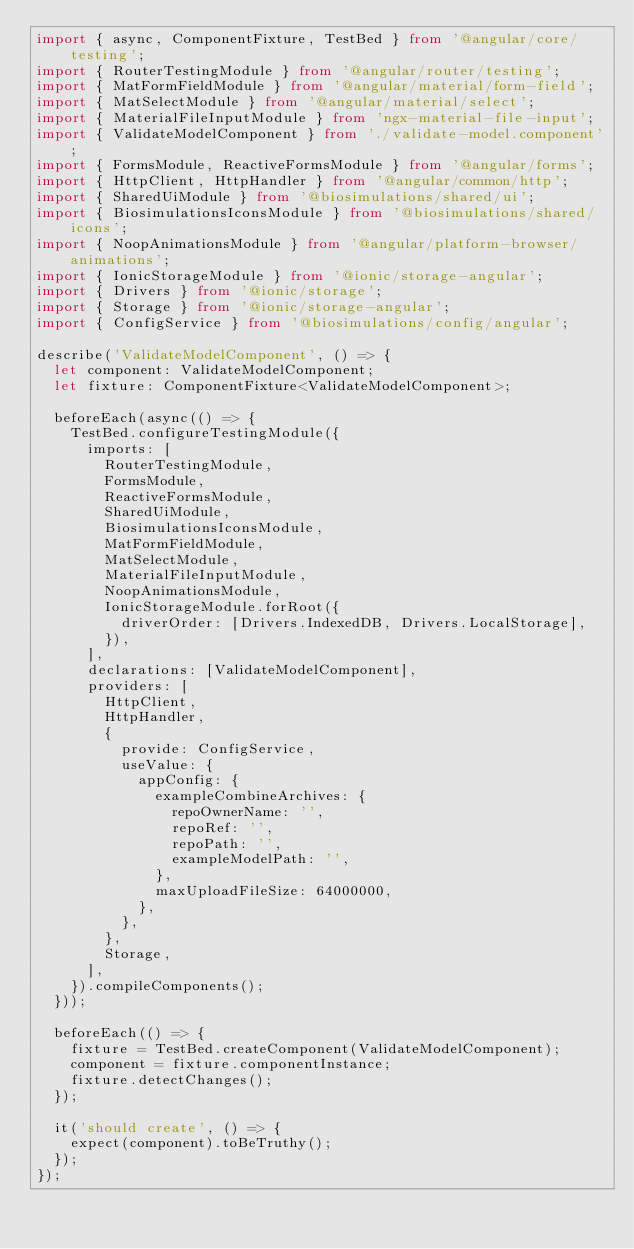Convert code to text. <code><loc_0><loc_0><loc_500><loc_500><_TypeScript_>import { async, ComponentFixture, TestBed } from '@angular/core/testing';
import { RouterTestingModule } from '@angular/router/testing';
import { MatFormFieldModule } from '@angular/material/form-field';
import { MatSelectModule } from '@angular/material/select';
import { MaterialFileInputModule } from 'ngx-material-file-input';
import { ValidateModelComponent } from './validate-model.component';
import { FormsModule, ReactiveFormsModule } from '@angular/forms';
import { HttpClient, HttpHandler } from '@angular/common/http';
import { SharedUiModule } from '@biosimulations/shared/ui';
import { BiosimulationsIconsModule } from '@biosimulations/shared/icons';
import { NoopAnimationsModule } from '@angular/platform-browser/animations';
import { IonicStorageModule } from '@ionic/storage-angular';
import { Drivers } from '@ionic/storage';
import { Storage } from '@ionic/storage-angular';
import { ConfigService } from '@biosimulations/config/angular';

describe('ValidateModelComponent', () => {
  let component: ValidateModelComponent;
  let fixture: ComponentFixture<ValidateModelComponent>;

  beforeEach(async(() => {
    TestBed.configureTestingModule({
      imports: [
        RouterTestingModule,
        FormsModule,
        ReactiveFormsModule,
        SharedUiModule,
        BiosimulationsIconsModule,
        MatFormFieldModule,
        MatSelectModule,
        MaterialFileInputModule,
        NoopAnimationsModule,
        IonicStorageModule.forRoot({
          driverOrder: [Drivers.IndexedDB, Drivers.LocalStorage],
        }),
      ],
      declarations: [ValidateModelComponent],
      providers: [
        HttpClient,
        HttpHandler,
        {
          provide: ConfigService,
          useValue: {
            appConfig: {
              exampleCombineArchives: {
                repoOwnerName: '',
                repoRef: '',
                repoPath: '',
                exampleModelPath: '',
              },
              maxUploadFileSize: 64000000,
            },
          },
        },
        Storage,
      ],
    }).compileComponents();
  }));

  beforeEach(() => {
    fixture = TestBed.createComponent(ValidateModelComponent);
    component = fixture.componentInstance;
    fixture.detectChanges();
  });

  it('should create', () => {
    expect(component).toBeTruthy();
  });
});
</code> 